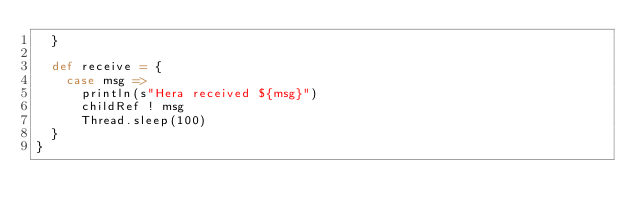<code> <loc_0><loc_0><loc_500><loc_500><_Scala_>  }

  def receive = {
    case msg =>
      println(s"Hera received ${msg}")
      childRef ! msg
      Thread.sleep(100)
  }
}
</code> 